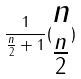Convert formula to latex. <formula><loc_0><loc_0><loc_500><loc_500>\frac { 1 } { \frac { n } { 2 } + 1 } ( \begin{matrix} n \\ \frac { n } { 2 } \end{matrix} )</formula> 